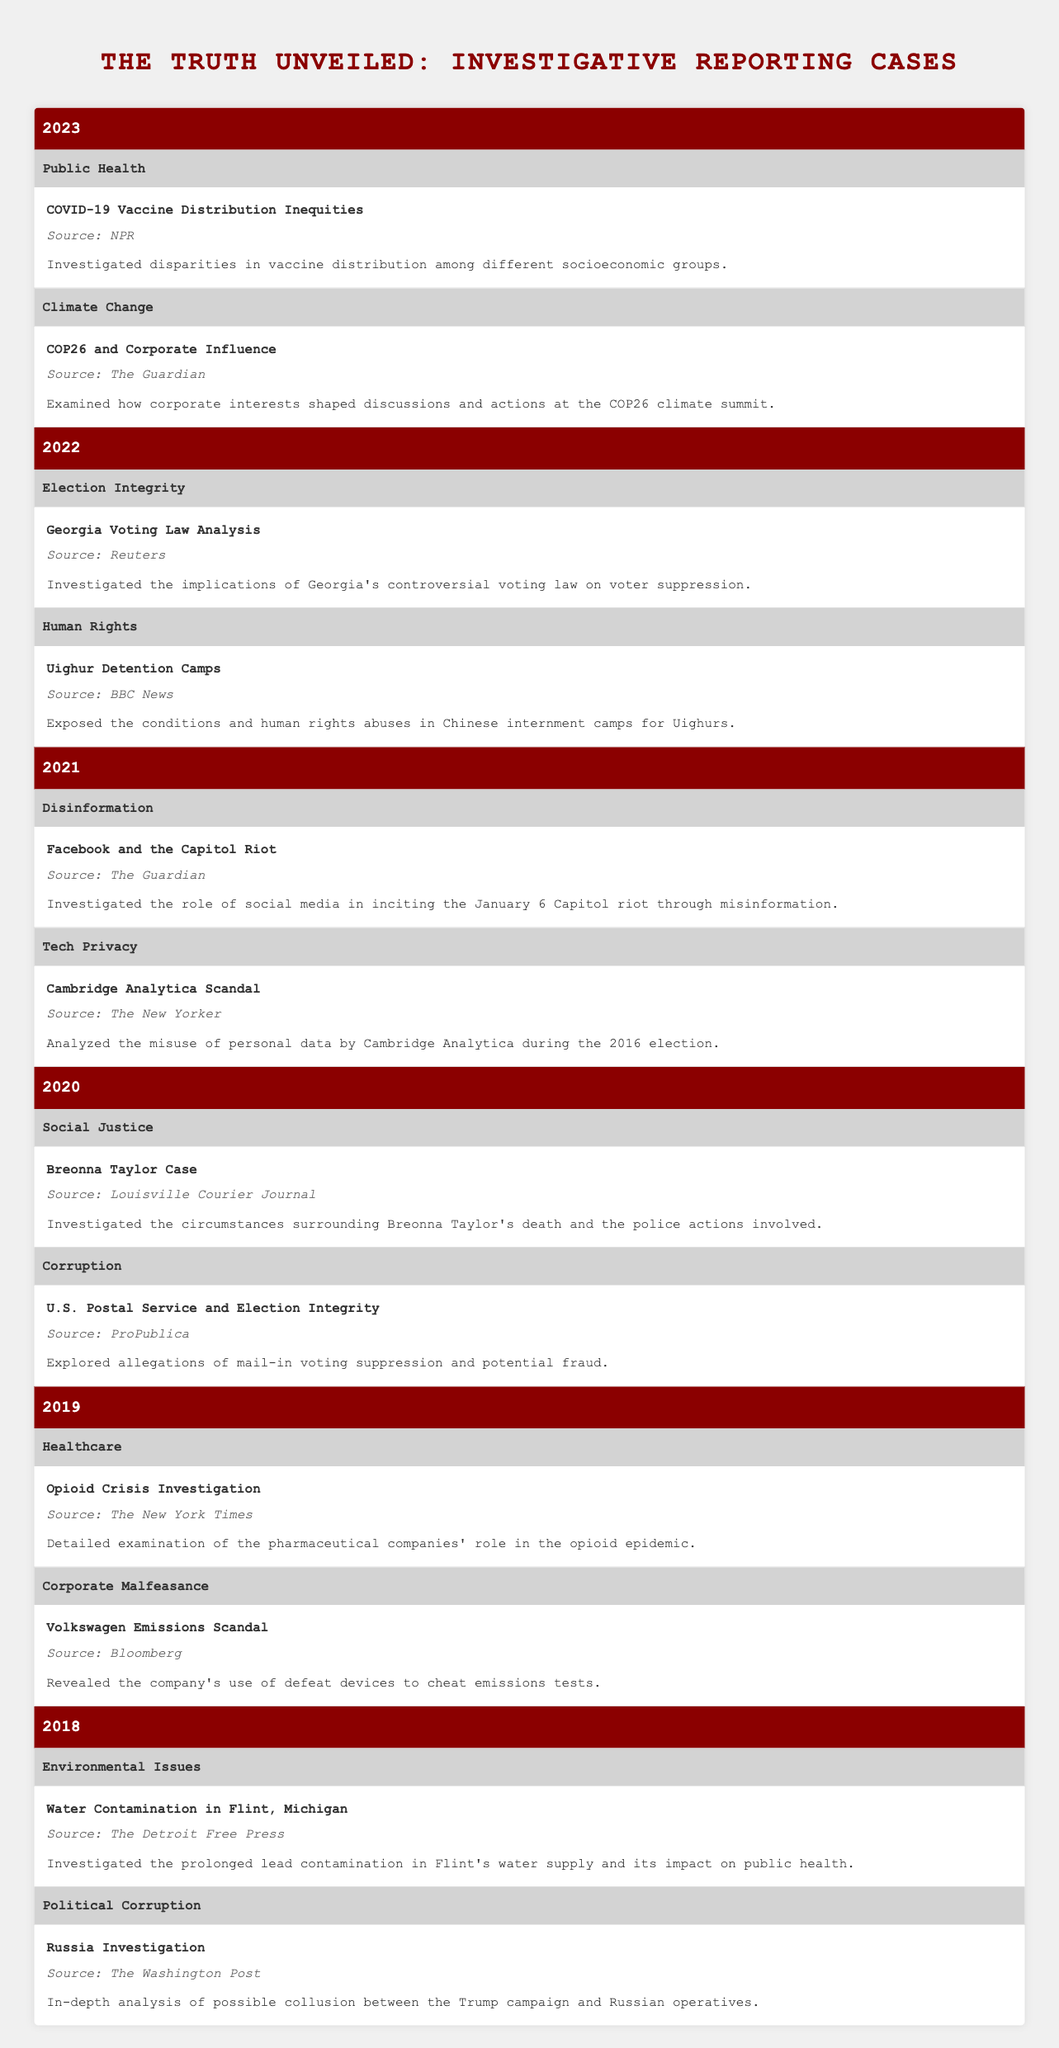What investigative reporting case related to corporate malfeasance occurred in 2019? In 2019, the case titled "Volkswagen Emissions Scandal" provided insights into the company's misuse of defeat devices to cheat emissions tests. This case is specifically categorized under the topic of corporate malfeasance for that year.
Answer: Volkswagen Emissions Scandal Which source reported on the Water Contamination case in Flint, Michigan? The information states that "The Detroit Free Press" was the source for the investigative case titled "Water Contamination in Flint, Michigan," which is categorized under Environmental Issues for the year 2018.
Answer: The Detroit Free Press True or False: The year 2021 focused exclusively on disinformation cases. In 2021, there were two topics: "Disinformation" and "Tech Privacy." The case "Cambridge Analytica Scandal," under Tech Privacy, indicates there is more than one focus area for the year. Therefore, the statement is false.
Answer: False How many investigative reporting cases were related to political corruption from 2018 to 2022? There was one case in 2018 titled "Russia Investigation" and no cases in the subsequent years 2019, 2020, 2021, or 2022. Summing these gives a total of 1 case related to political corruption from 2018 to 2022.
Answer: 1 What was the main focus of the 2020 case concerning social justice? The case titled "Breonna Taylor Case," focused on investigating the circumstances surrounding the death of Breonna Taylor and the police actions involved, categorizing this under Social Justice for 2020.
Answer: Breonna Taylor Case 